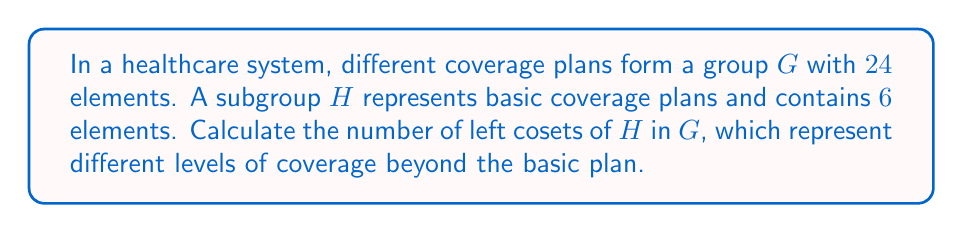Help me with this question. To solve this problem, we'll use the following steps:

1) Recall the Lagrange's Theorem: For a finite group $G$ and a subgroup $H$ of $G$, the order of $H$ divides the order of $G$. Moreover, the number of left cosets of $H$ in $G$ is equal to the index of $H$ in $G$, denoted as $[G:H]$.

2) The index $[G:H]$ is given by the formula:

   $$[G:H] = \frac{|G|}{|H|}$$

   where $|G|$ is the order of group $G$ and $|H|$ is the order of subgroup $H$.

3) In this case:
   $|G| = 24$ (total number of coverage plans)
   $|H| = 6$ (number of basic coverage plans)

4) Substituting these values into the formula:

   $$[G:H] = \frac{24}{6} = 4$$

5) Therefore, there are 4 left cosets of $H$ in $G$.

Each of these cosets represents a different level of coverage beyond the basic plan. For instance, they could represent bronze, silver, gold, and platinum levels of coverage, each building upon the basic coverage represented by $H$.
Answer: The number of left cosets of $H$ in $G$ is $4$. 